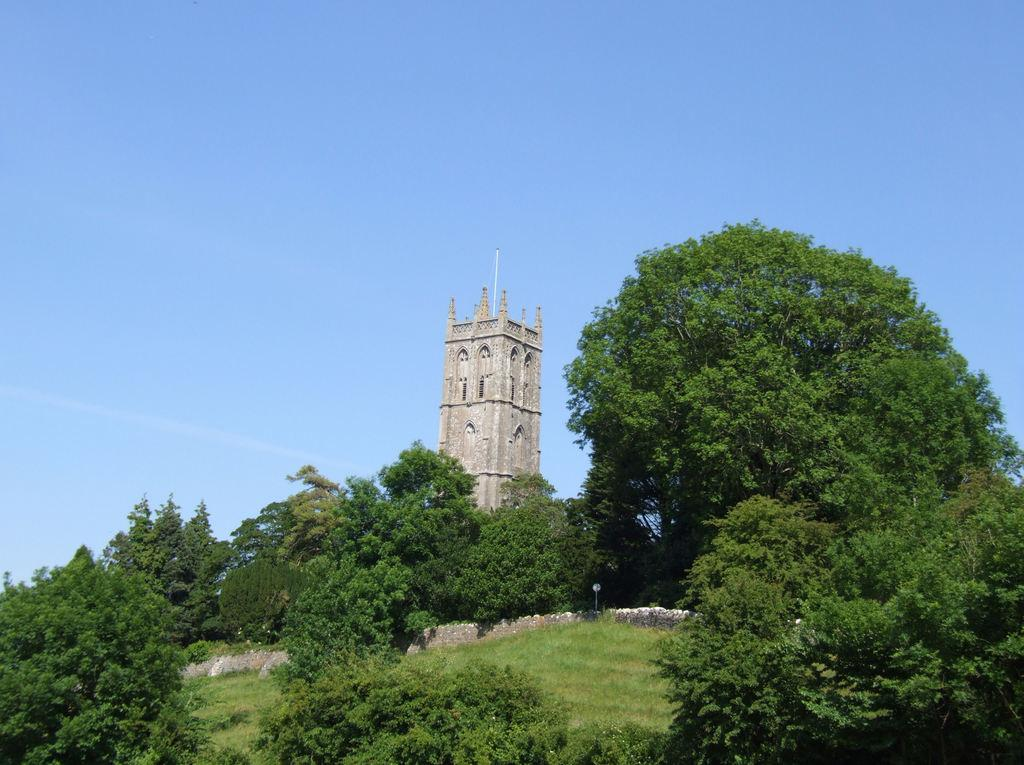What type of vegetation is present in the image? There is grass in the image. What can be seen in the front of the image? There are trees in the front of the image. What structure is visible in the background of the image? There is a building in the background of the image. What part of the natural environment is visible in the image? The sky is visible in the background of the image. What type of lamp is hanging from the tree in the image? There is no lamp present in the image; it features grass, trees, a building, and the sky. What is the interest rate of the loan mentioned in the image? There is no mention of a loan or interest rate in the image. 